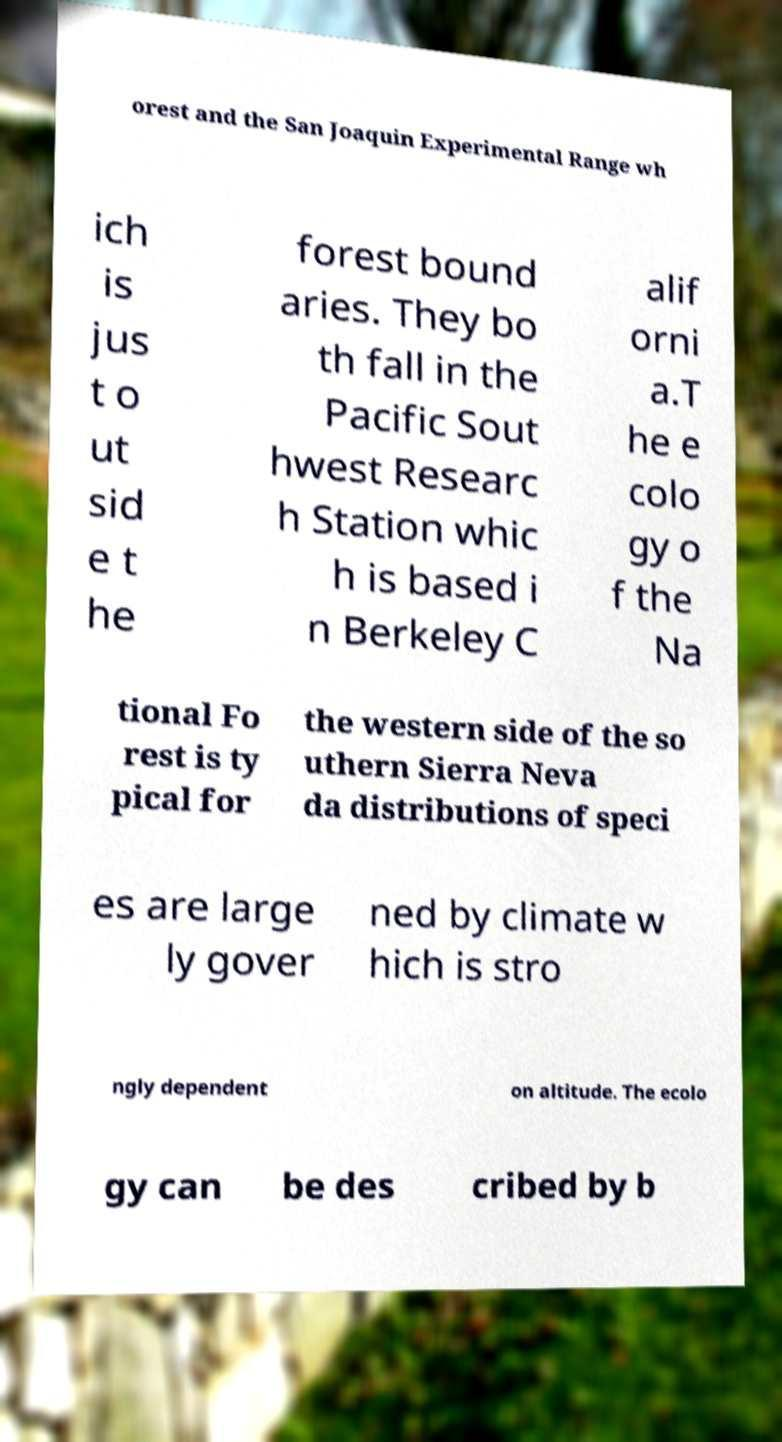What messages or text are displayed in this image? I need them in a readable, typed format. orest and the San Joaquin Experimental Range wh ich is jus t o ut sid e t he forest bound aries. They bo th fall in the Pacific Sout hwest Researc h Station whic h is based i n Berkeley C alif orni a.T he e colo gy o f the Na tional Fo rest is ty pical for the western side of the so uthern Sierra Neva da distributions of speci es are large ly gover ned by climate w hich is stro ngly dependent on altitude. The ecolo gy can be des cribed by b 